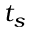Convert formula to latex. <formula><loc_0><loc_0><loc_500><loc_500>t _ { s }</formula> 